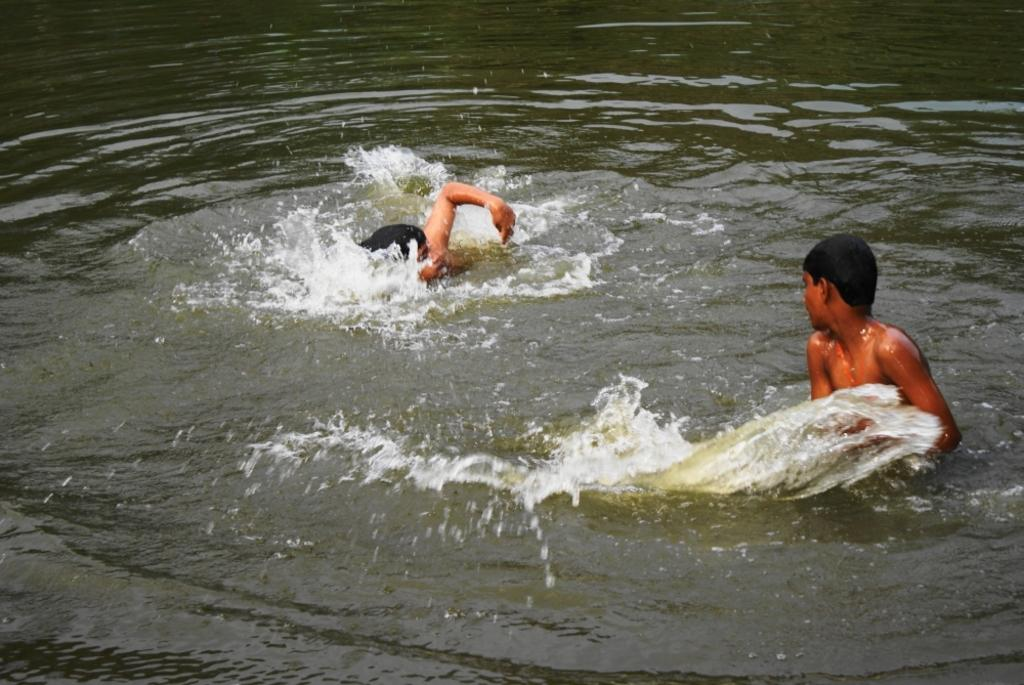How many people are in the image? There are two persons in the image. What are the two persons doing in the image? The two persons are swimming in the water. What type of seat can be seen in the image? There is no seat present in the image; it features two persons swimming in the water. What occupation might the persons in the image have, such as a carpenter? There is no indication of the persons' occupations in the image; they are simply swimming in the water. 